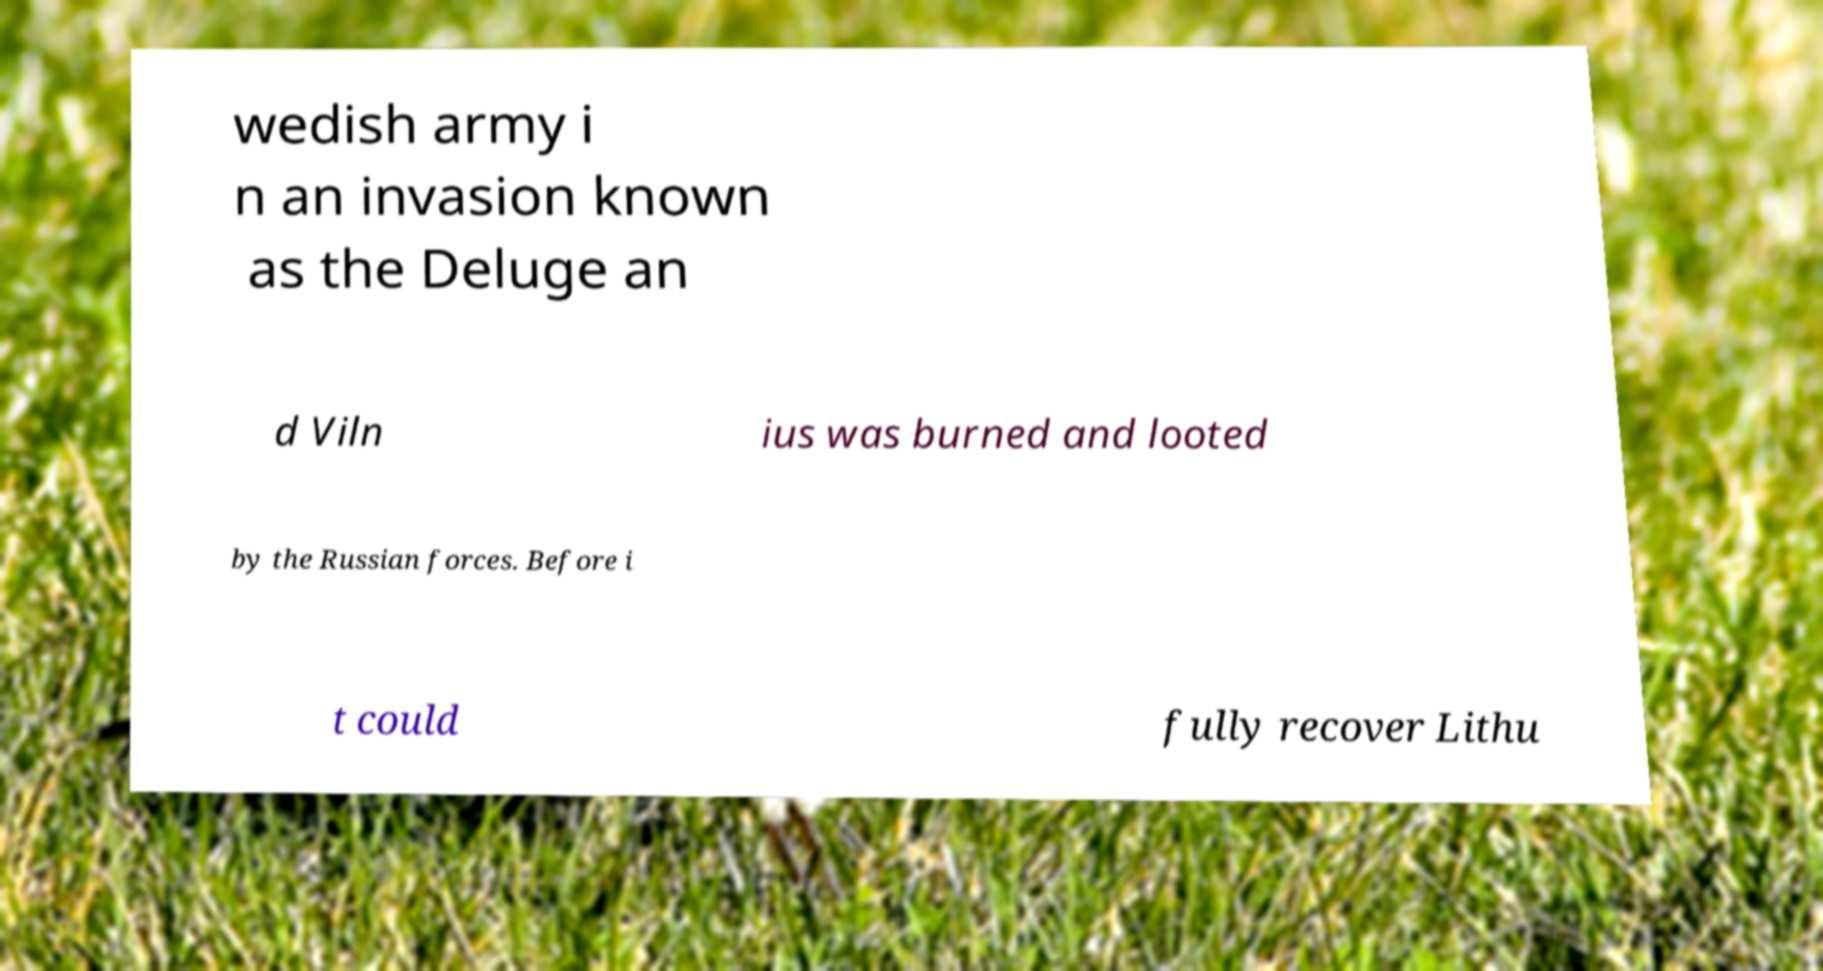Can you accurately transcribe the text from the provided image for me? wedish army i n an invasion known as the Deluge an d Viln ius was burned and looted by the Russian forces. Before i t could fully recover Lithu 